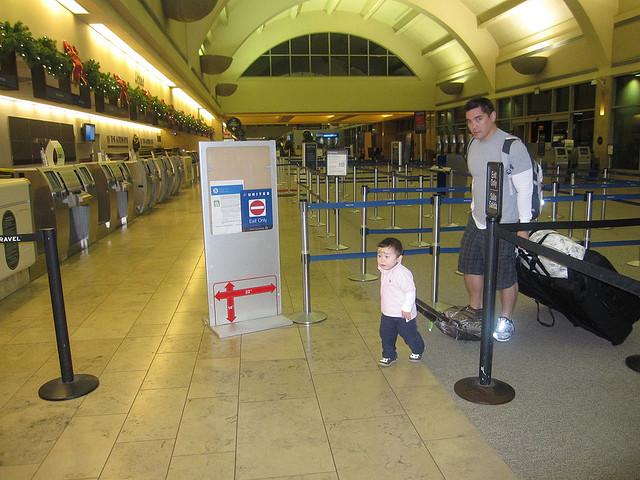What holiday season is it?
Give a very brief answer. Christmas. Is the child pulling his own bag?
Concise answer only. Yes. What mode of travel will this man and child take?
Answer briefly. Airplane. 